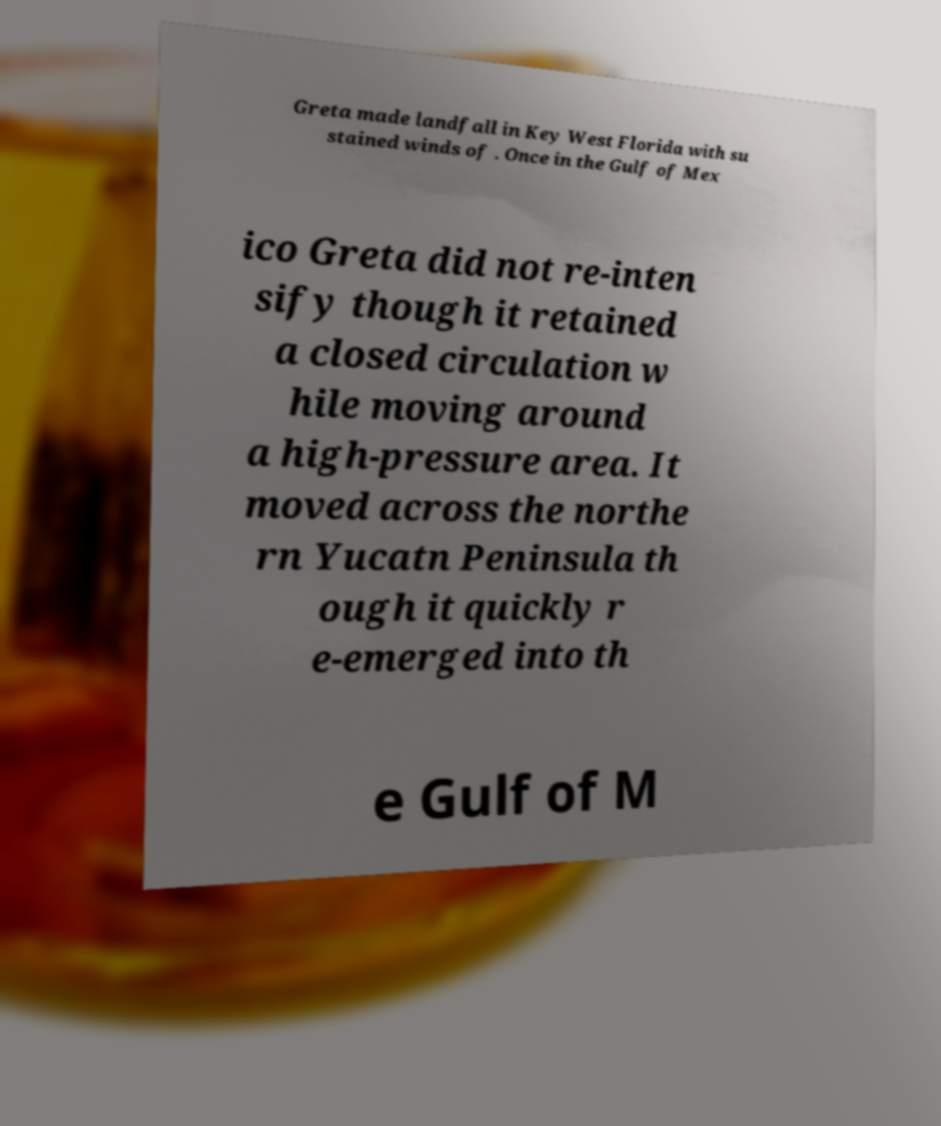Could you extract and type out the text from this image? Greta made landfall in Key West Florida with su stained winds of . Once in the Gulf of Mex ico Greta did not re-inten sify though it retained a closed circulation w hile moving around a high-pressure area. It moved across the northe rn Yucatn Peninsula th ough it quickly r e-emerged into th e Gulf of M 